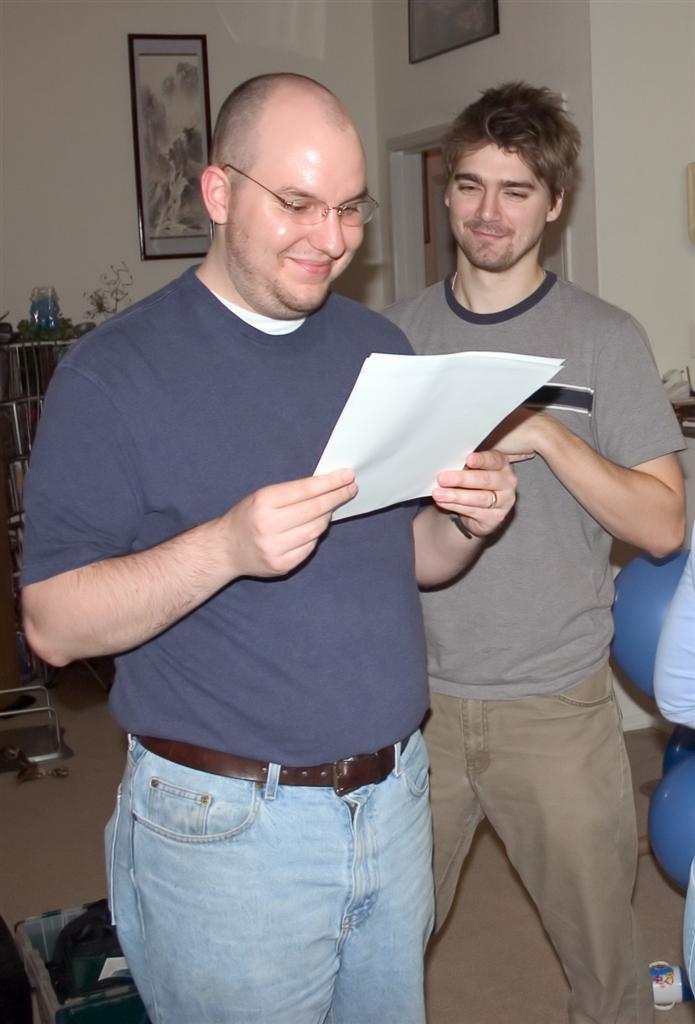Can you describe this image briefly? In this picture, there are two men. One of the man is wearing blue t shirt, blue jeans and holding a paper. Beside him, there is another man wearing a grey t shirt and cream trousers. In the background, there is a wall with frames. 